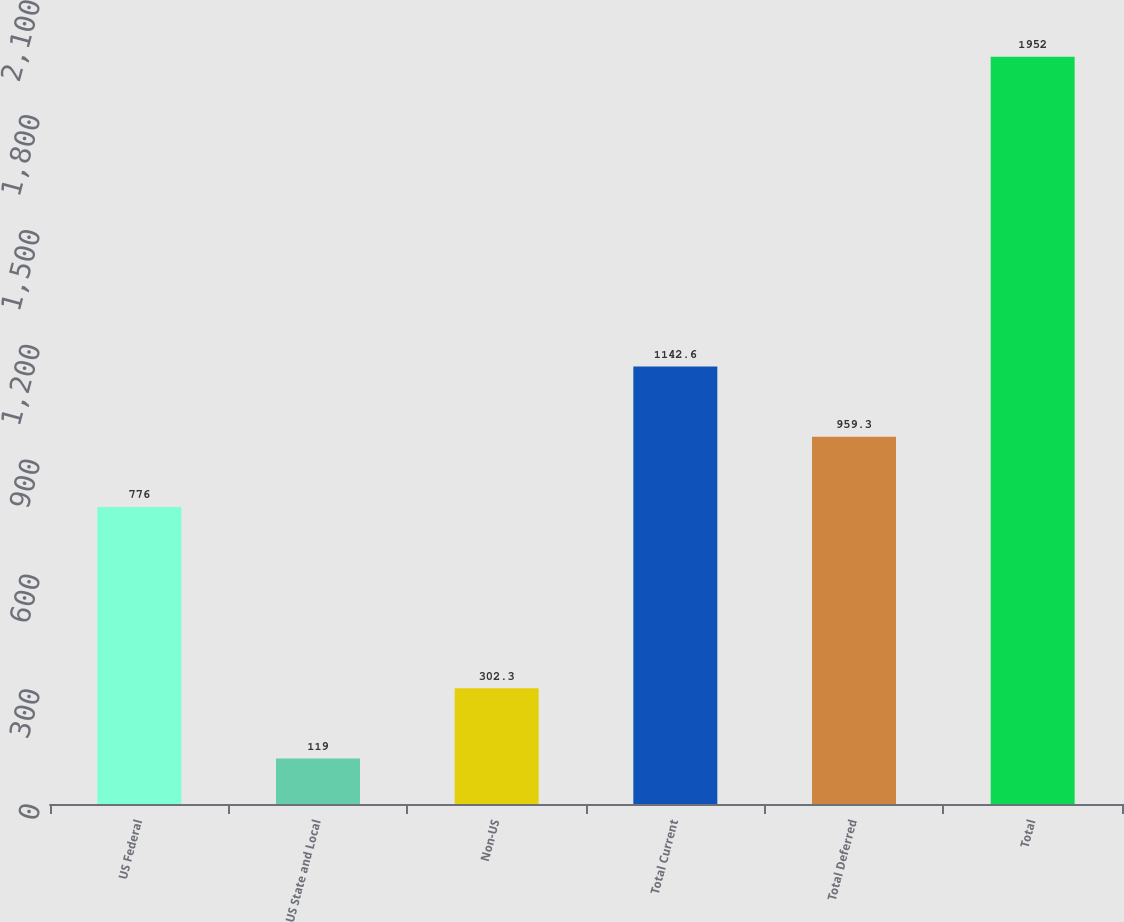<chart> <loc_0><loc_0><loc_500><loc_500><bar_chart><fcel>US Federal<fcel>US State and Local<fcel>Non-US<fcel>Total Current<fcel>Total Deferred<fcel>Total<nl><fcel>776<fcel>119<fcel>302.3<fcel>1142.6<fcel>959.3<fcel>1952<nl></chart> 